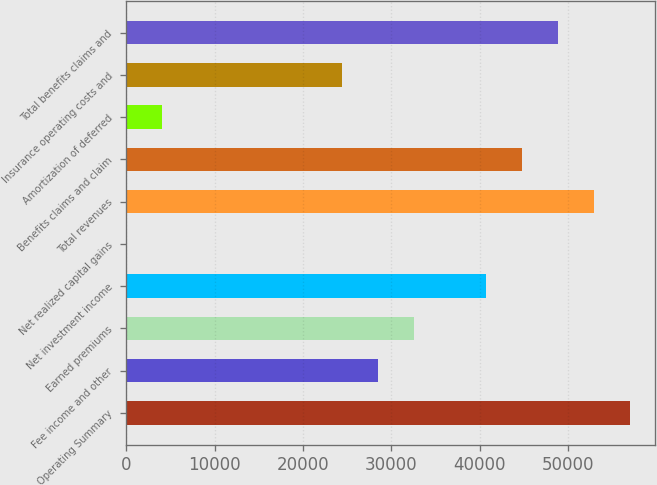Convert chart to OTSL. <chart><loc_0><loc_0><loc_500><loc_500><bar_chart><fcel>Operating Summary<fcel>Fee income and other<fcel>Earned premiums<fcel>Net investment income<fcel>Net realized capital gains<fcel>Total revenues<fcel>Benefits claims and claim<fcel>Amortization of deferred<fcel>Insurance operating costs and<fcel>Total benefits claims and<nl><fcel>56987.2<fcel>28495.1<fcel>32565.4<fcel>40706<fcel>3<fcel>52916.9<fcel>44776.3<fcel>4073.3<fcel>24424.8<fcel>48846.6<nl></chart> 